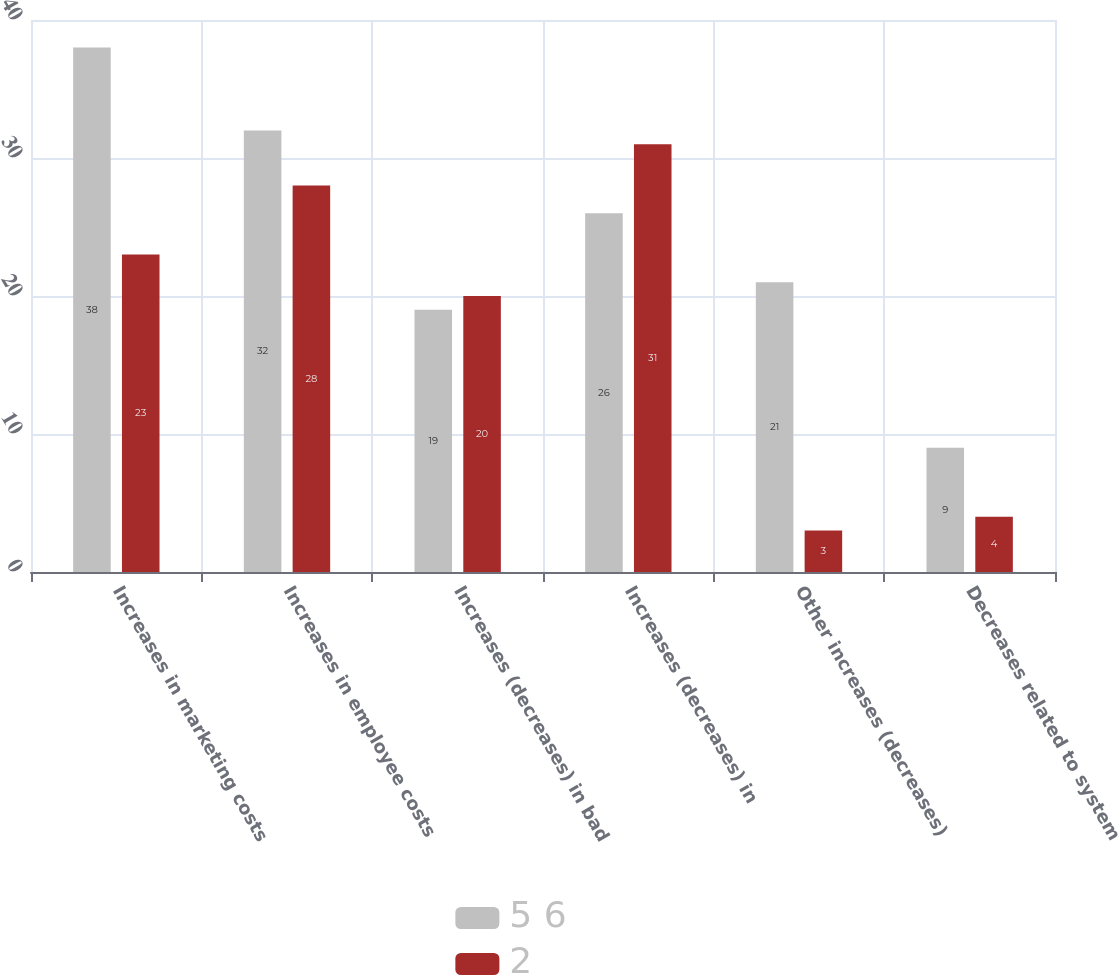<chart> <loc_0><loc_0><loc_500><loc_500><stacked_bar_chart><ecel><fcel>Increases in marketing costs<fcel>Increases in employee costs<fcel>Increases (decreases) in bad<fcel>Increases (decreases) in<fcel>Other increases (decreases)<fcel>Decreases related to system<nl><fcel>5 6<fcel>38<fcel>32<fcel>19<fcel>26<fcel>21<fcel>9<nl><fcel>2<fcel>23<fcel>28<fcel>20<fcel>31<fcel>3<fcel>4<nl></chart> 